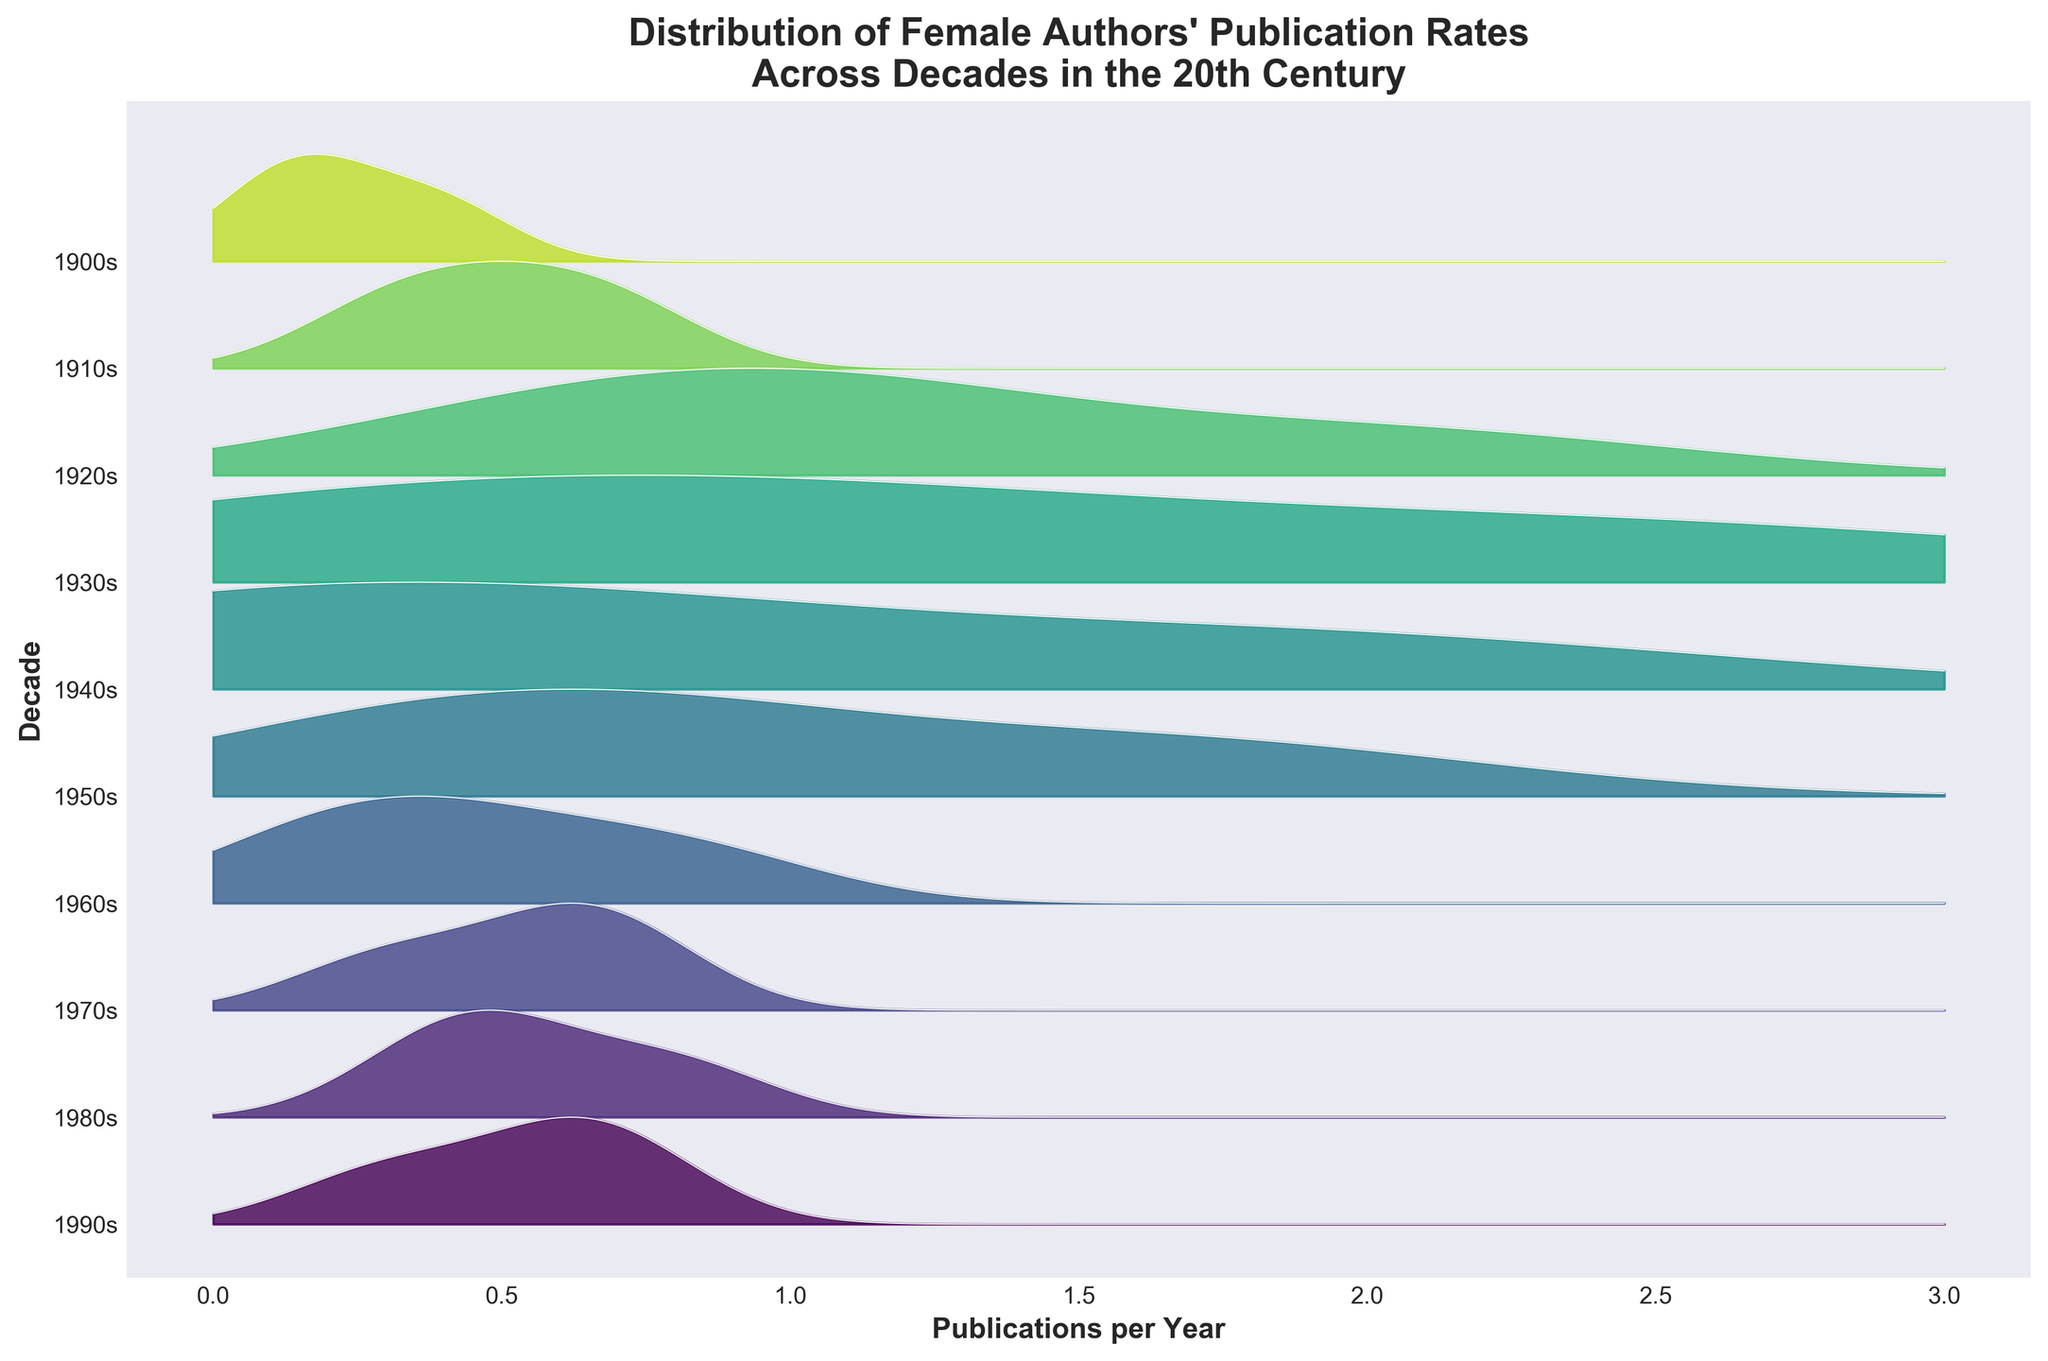What is the title of this figure? The title is located at the top of the figure and it summarizes the main subject of the plot.
Answer: Distribution of Female Authors' Publication Rates Across Decades in the 20th Century Which decade has the widest distribution of publication rates? To determine the widest distribution, look for the decade that has the broadest range of values along the x-axis.
Answer: 1920s What are the units used for the x-axis? Examine the x-axis label to identify the units.
Answer: Publications per Year In which decade did Agatha Christie publish the most per year? Check the density peaks for each decade Agatha Christie appears in.
Answer: 1930s How many authors were included in the 1980s? Count the authors listed under the 1980s in the data provided.
Answer: 3 Which decade has the highest peak in publication rates? Identify the decade with the tallest peak in the density curves.
Answer: 1930s Compare the publication rates of Virginia Woolf in the 1920s and 1930s. In which decade did she have a higher rate? Locate the positions and heights of Virginia Woolf's data points in both decades.
Answer: 1920s What is the average of the publication rates for Virginia Woolf across the decades she published? Add up the publication rates of Virginia Woolf and divide by the number of decades she published. (0.2 + 0.5 + 1.2 + 0.8) / 4 = 0.675
Answer: 0.675 What color represents the 1920s in the plot? Observe the unique color associated with the decade label for the 1920s.
Answer: (specific color tone may vary, describe as per figure) How does the density of publications in the 1940s compare to that in the 1970s? Compare the shapes and heights of the density curves for the 1940s and 1970s along the x-axis.
Answer: 1940s has a higher density 